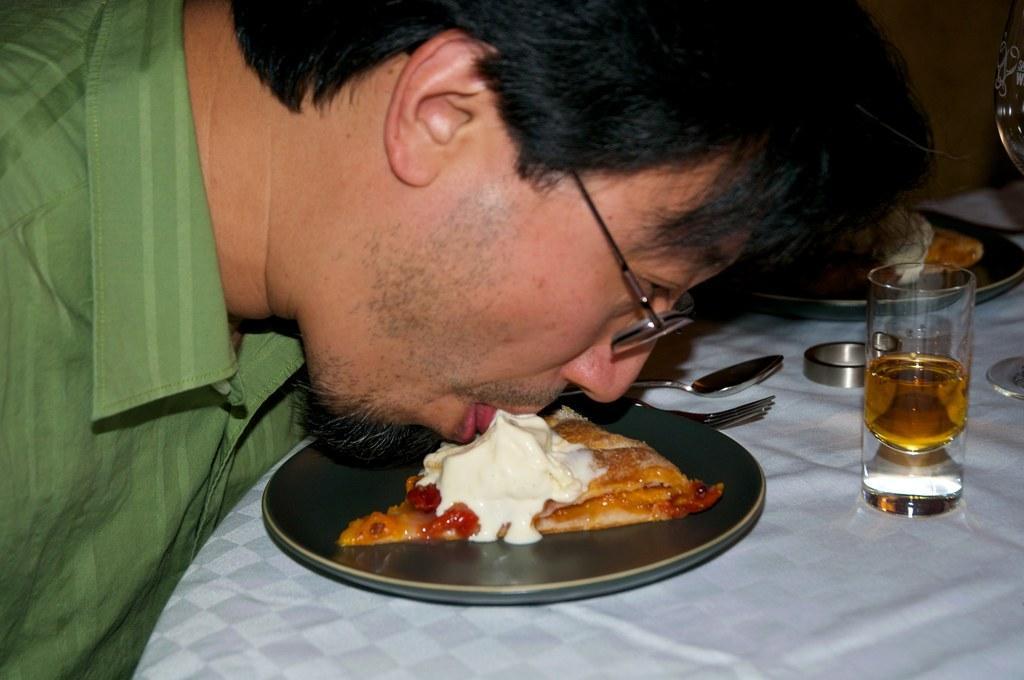Please provide a concise description of this image. In the center of the image there is a table. On the table we can see spoons, glass, food item on plate are present. On the left side of the image a man is tasting a food. 